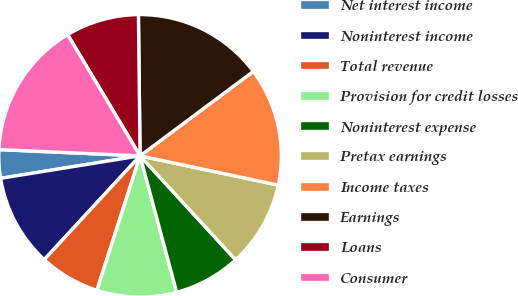Convert chart. <chart><loc_0><loc_0><loc_500><loc_500><pie_chart><fcel>Net interest income<fcel>Noninterest income<fcel>Total revenue<fcel>Provision for credit losses<fcel>Noninterest expense<fcel>Pretax earnings<fcel>Income taxes<fcel>Earnings<fcel>Loans<fcel>Consumer<nl><fcel>3.25%<fcel>10.59%<fcel>6.92%<fcel>9.12%<fcel>7.65%<fcel>9.85%<fcel>13.52%<fcel>14.99%<fcel>8.39%<fcel>15.72%<nl></chart> 